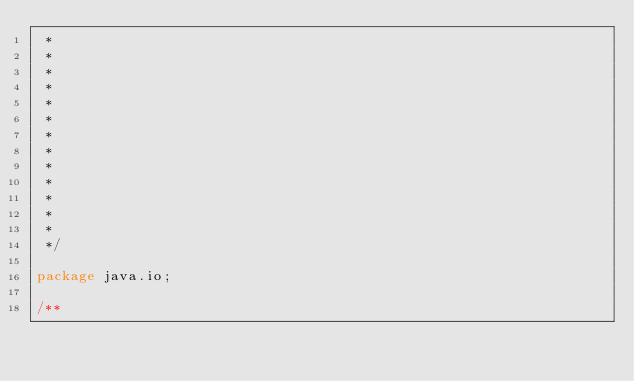Convert code to text. <code><loc_0><loc_0><loc_500><loc_500><_Java_> *
 *
 *
 *
 *
 *
 *
 *
 *
 *
 *
 *
 *
 */

package java.io;

/**</code> 